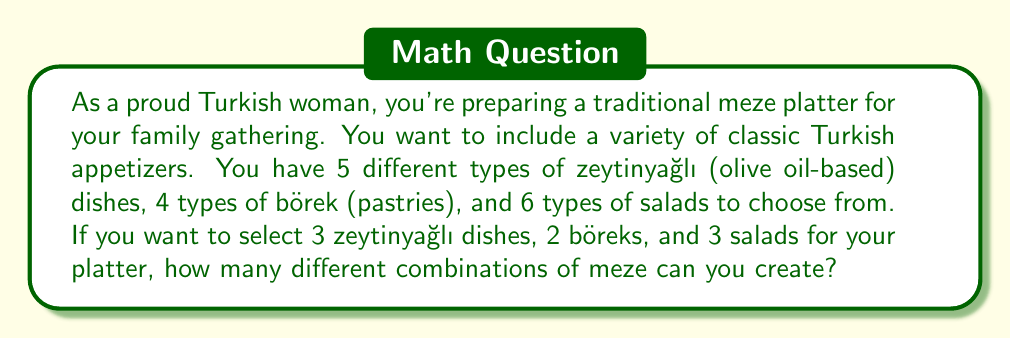Can you solve this math problem? Let's approach this step-by-step using the combination formula:

1. For zeytinyağlı dishes:
   We need to choose 3 out of 5 dishes. This can be calculated using the combination formula:
   $$\binom{5}{3} = \frac{5!}{3!(5-3)!} = \frac{5!}{3!2!} = 10$$

2. For börek:
   We need to choose 2 out of 4 types. Using the combination formula:
   $$\binom{4}{2} = \frac{4!}{2!(4-2)!} = \frac{4!}{2!2!} = 6$$

3. For salads:
   We need to choose 3 out of 6 types. Using the combination formula:
   $$\binom{6}{3} = \frac{6!}{3!(6-3)!} = \frac{6!}{3!3!} = 20$$

Now, according to the multiplication principle, to find the total number of possible combinations, we multiply these individual results:

$$10 \times 6 \times 20 = 1,200$$

Therefore, the total number of different meze platter combinations is 1,200.
Answer: 1,200 different combinations 